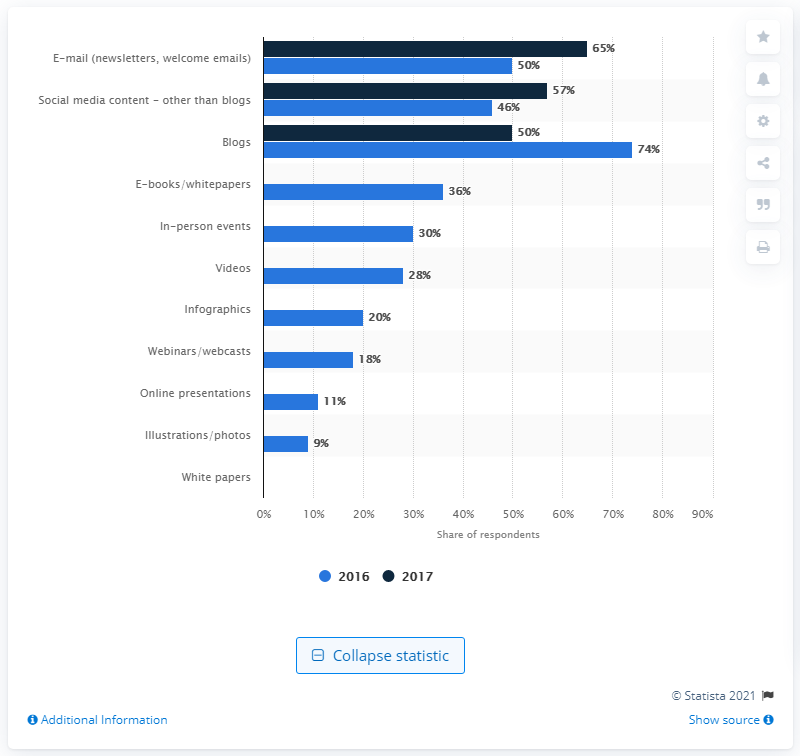Specify some key components in this picture. In the year 2016, marketers in the UK began to employ content marketing tactics. 